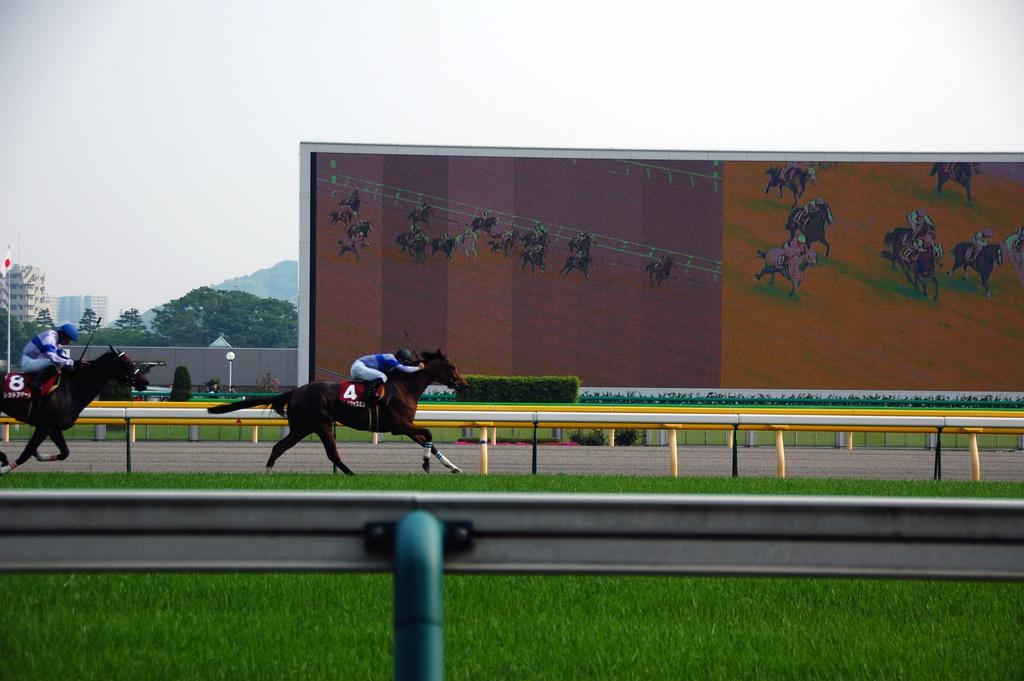Could you give a brief overview of what you see in this image? There are two horses running. On the horse there are numbers. Also there are persons wearing helmets sitting. At the bottom there is a pole with a road. On the ground there is grass. Also there are railings. In the back there are bushes. Also there is a wall. On the wall there are images of horse racing. In the background there are trees, buildings and sky. 